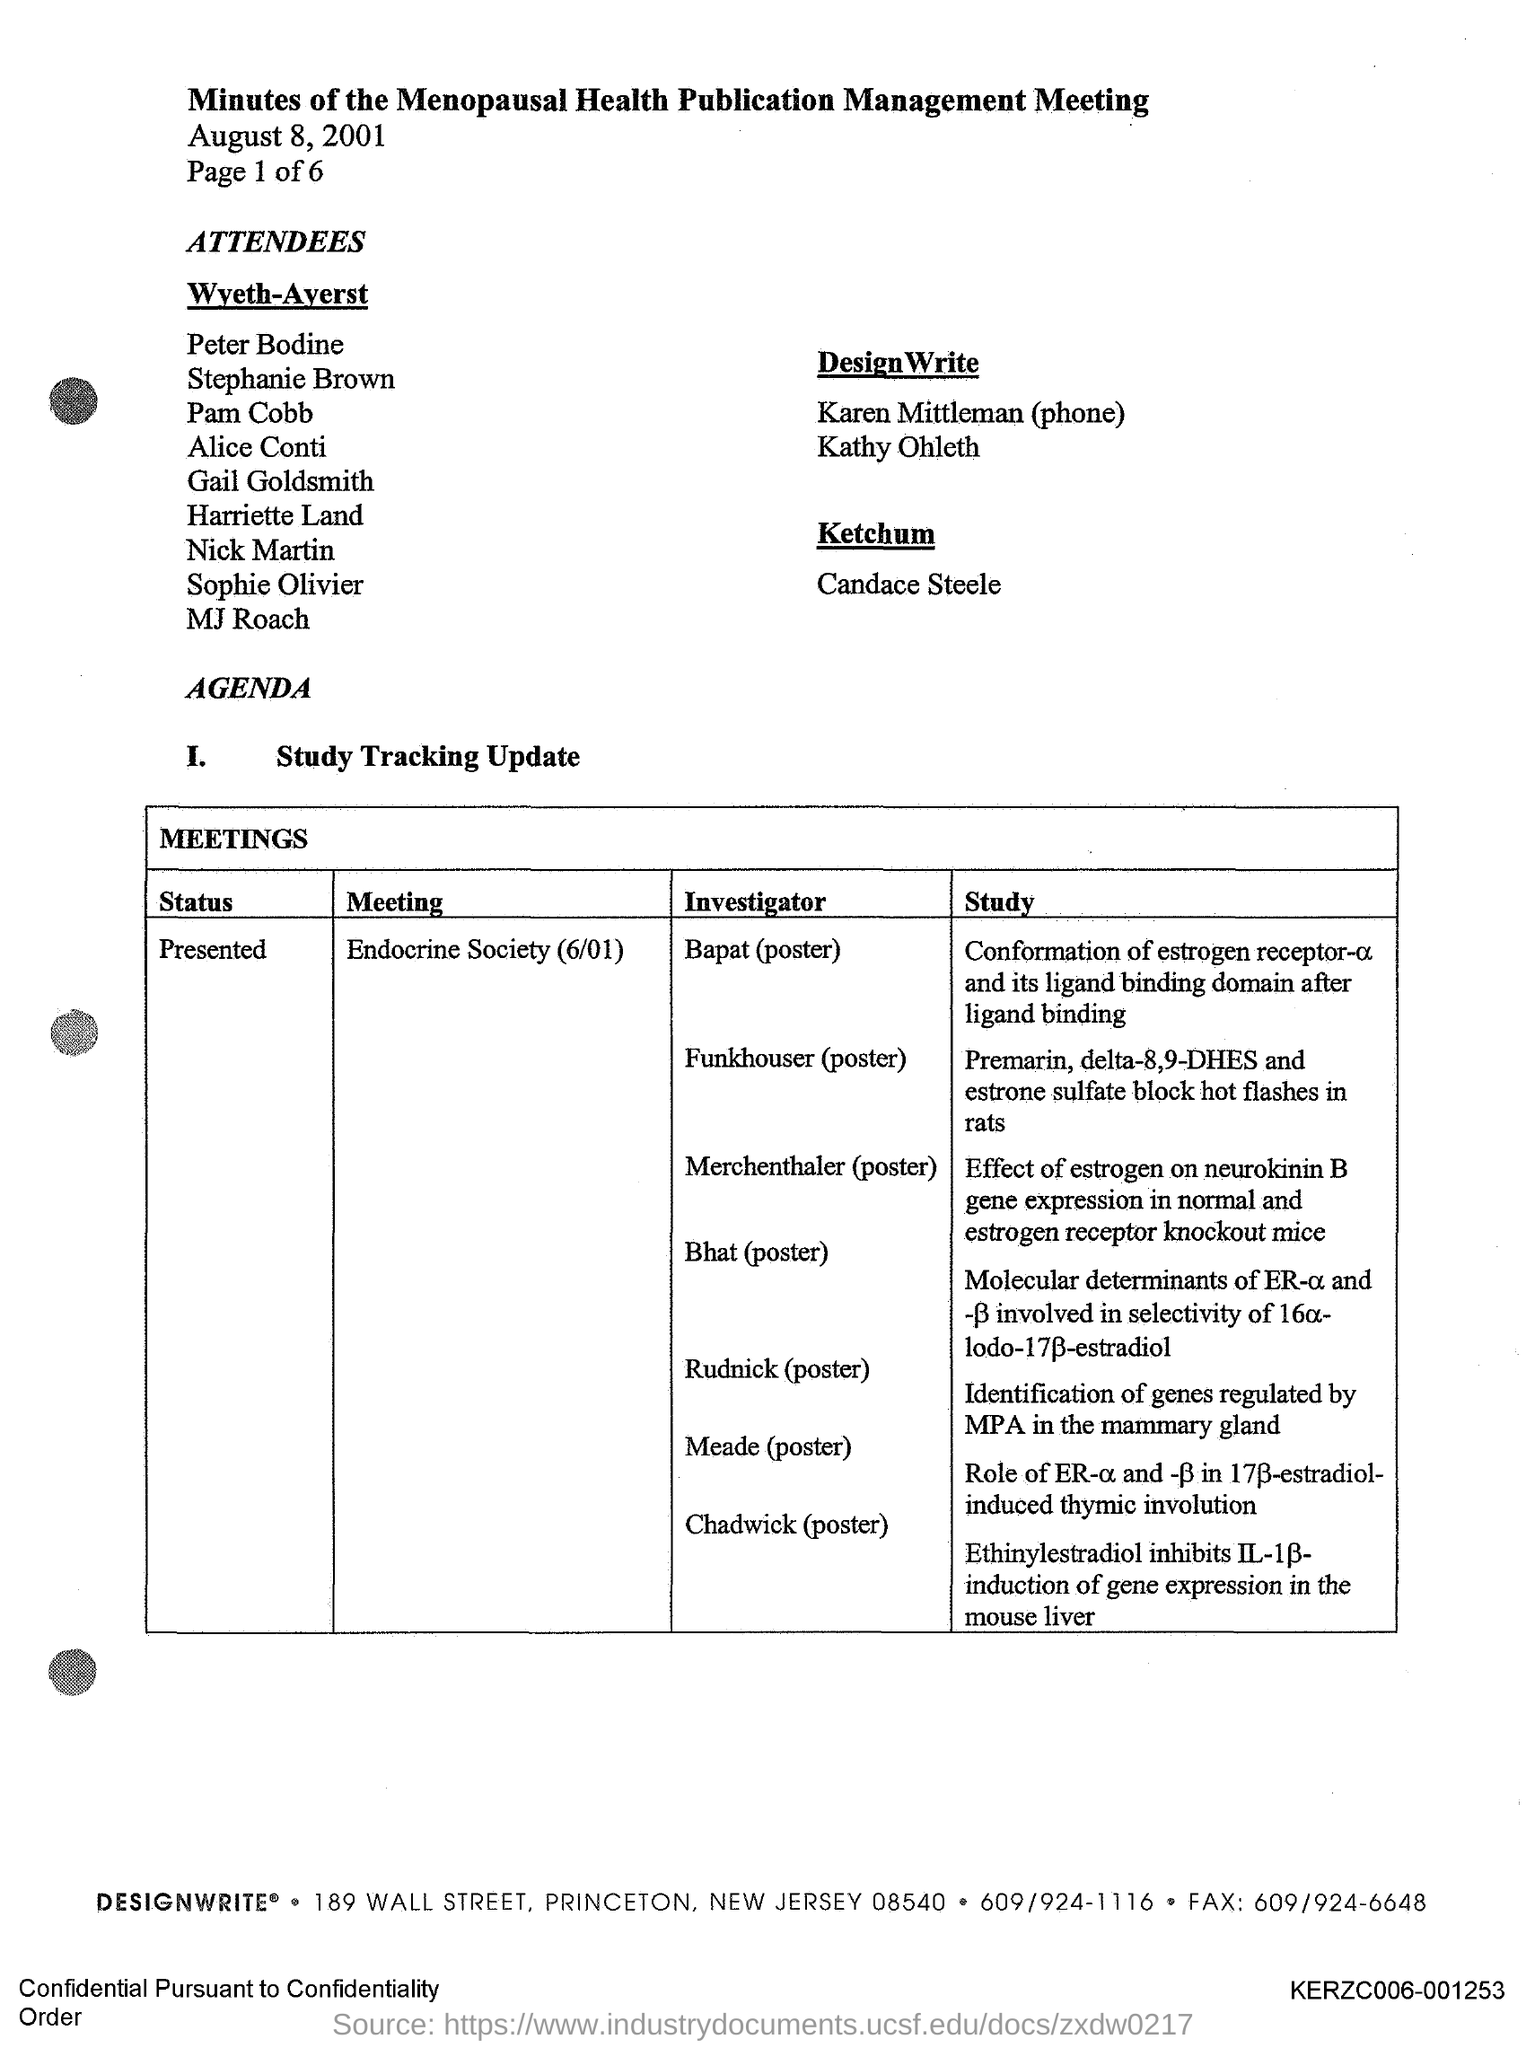Highlight a few significant elements in this photo. The document in question is titled "Minutes of the Menopausal Health Publication Management Meeting. 